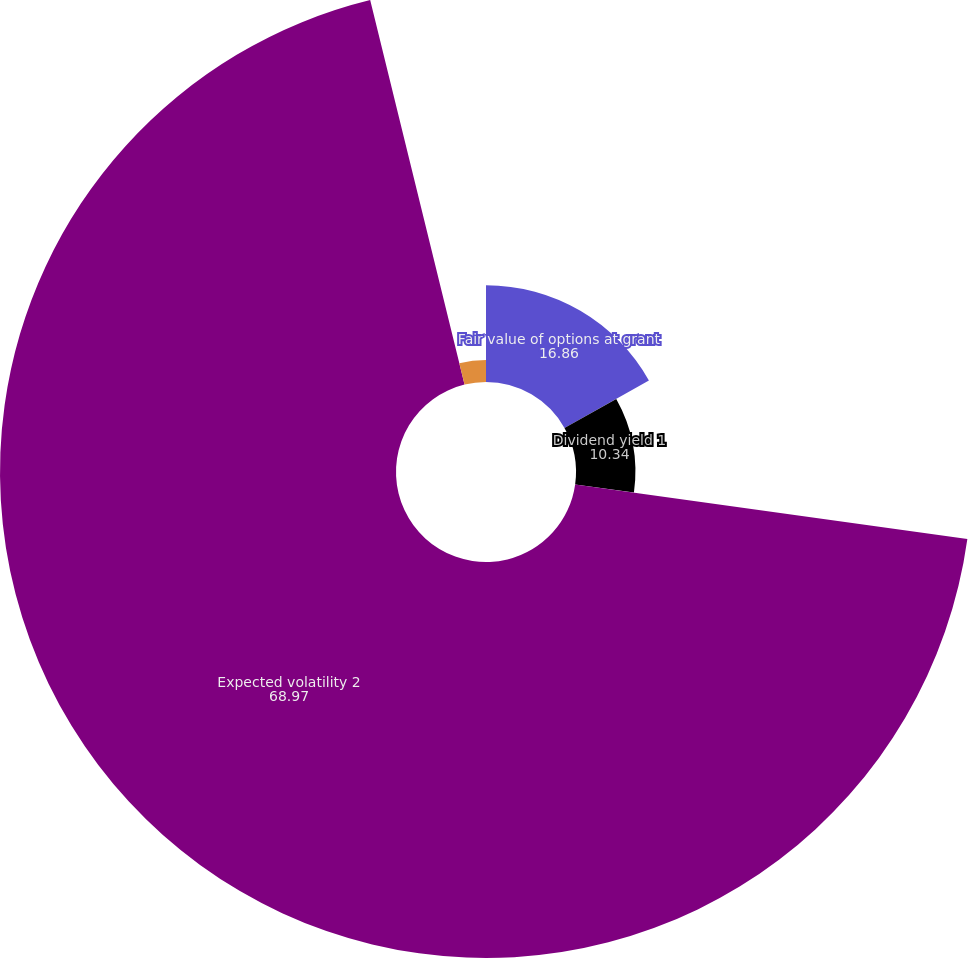<chart> <loc_0><loc_0><loc_500><loc_500><pie_chart><fcel>Fair value of options at grant<fcel>Dividend yield 1<fcel>Expected volatility 2<fcel>Risk-free interest rate 3<nl><fcel>16.86%<fcel>10.34%<fcel>68.97%<fcel>3.83%<nl></chart> 